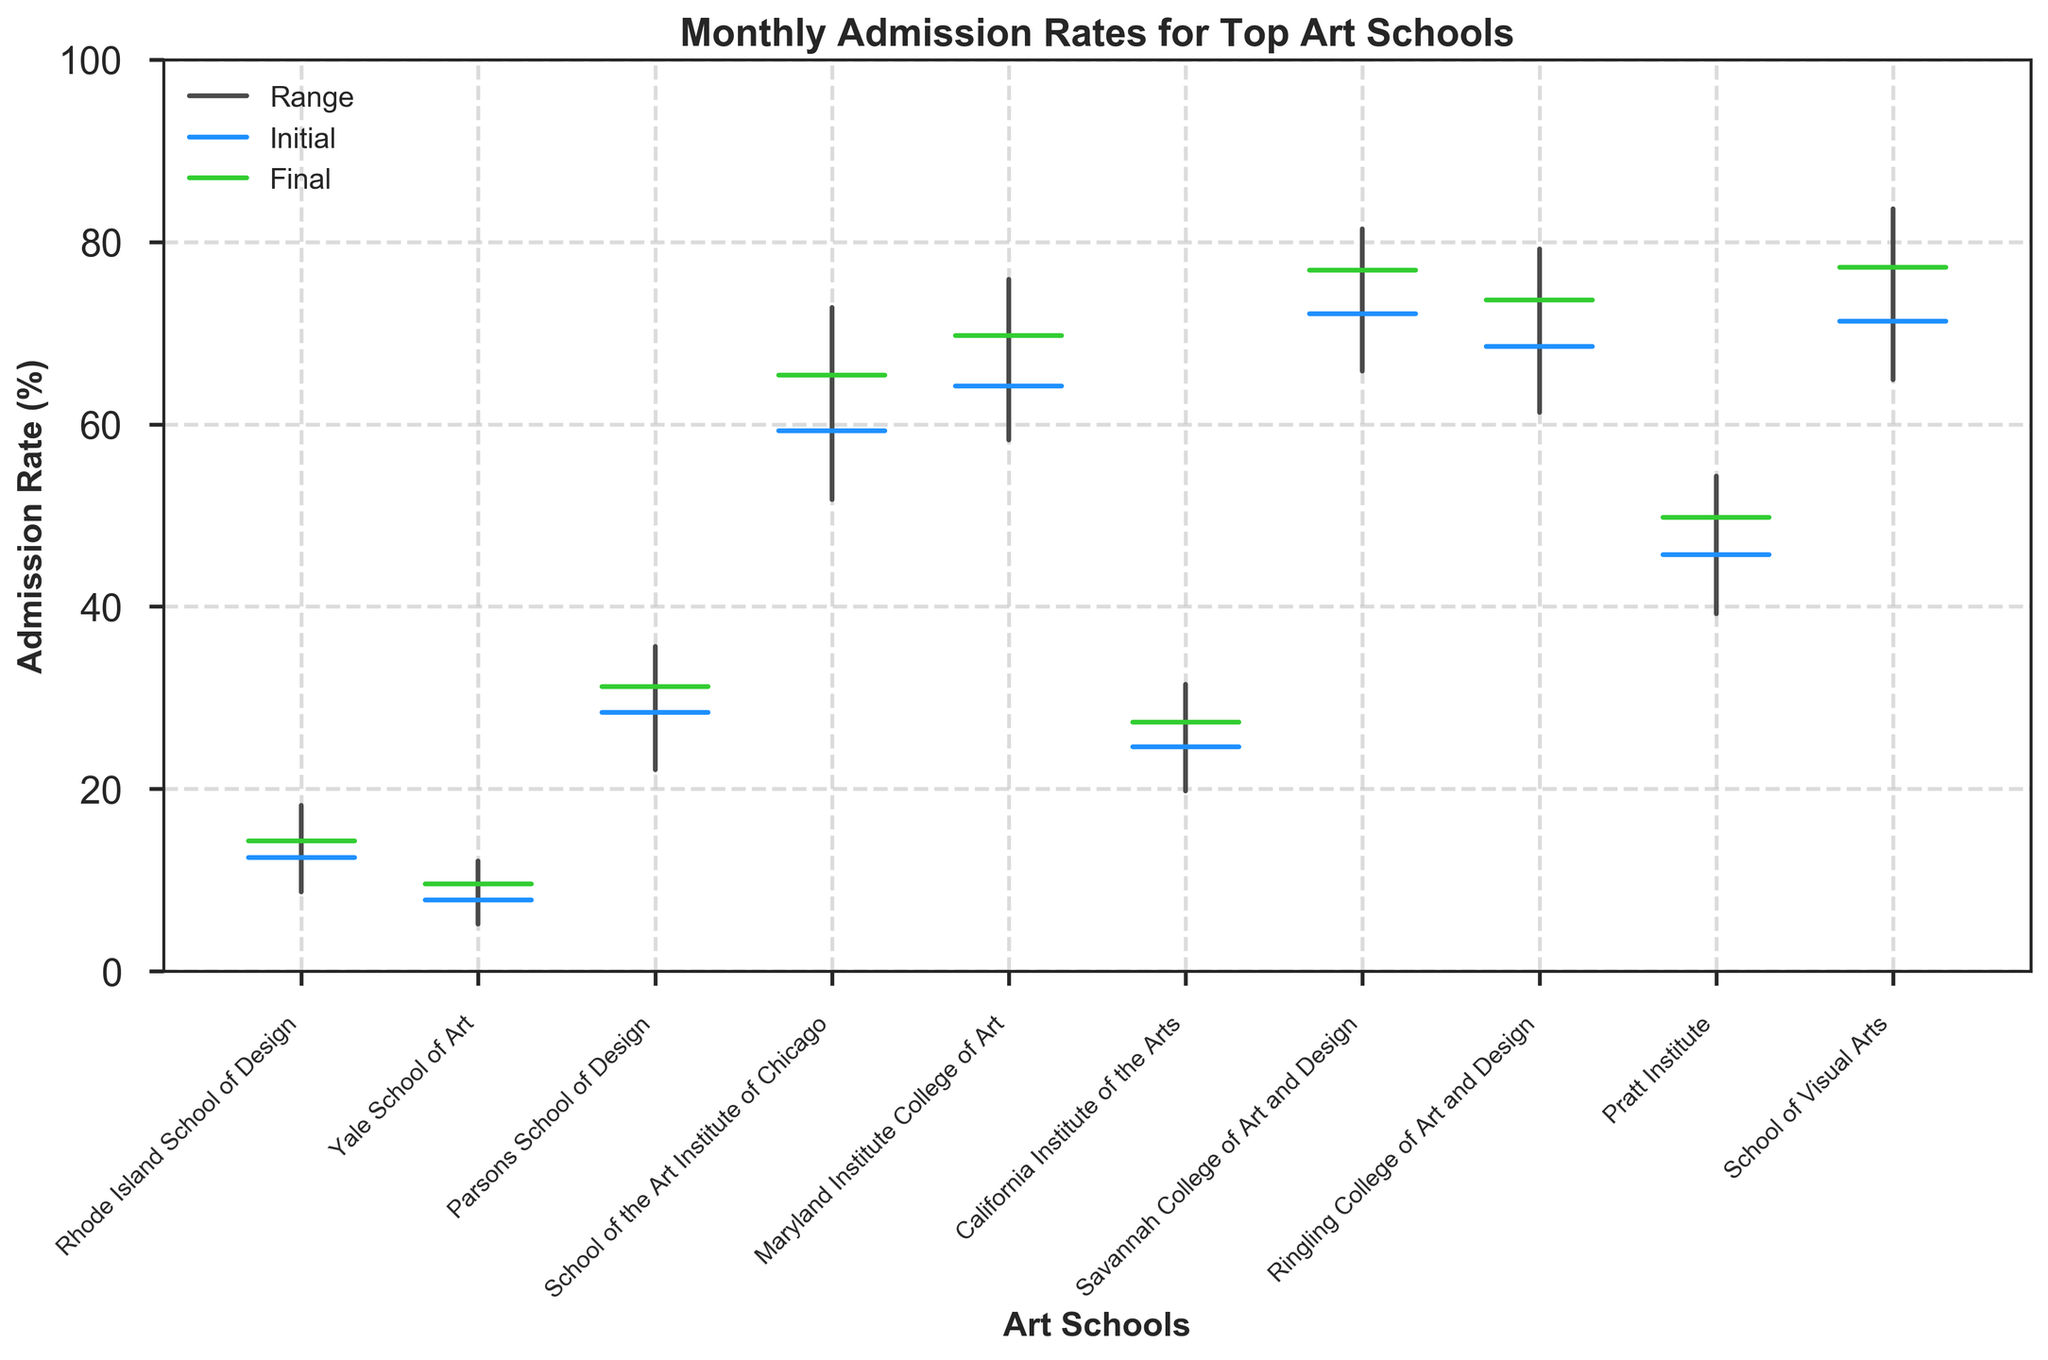What's the title of the figure? The title can be found at the top of the figure, indicating the context of the data presented. The title is "Monthly Admission Rates for Top Art Schools."
Answer: Monthly Admission Rates for Top Art Schools Which school has the highest peak admission rate? To determine this, locate the school with the highest point on the 'Peak' line in the figure. The School of Visual Arts has the highest peak rate at 83.6%.
Answer: School of Visual Arts Which school saw the greatest difference between its lowest and peak admission rates? Calculate the difference between the peak and lowest rates for each school and identify the largest gap. The School of Visual Arts has the greatest difference (83.6 - 64.9 = 18.7 percentage points).
Answer: School of Visual Arts What is the final acceptance percentage for Rhode Island School of Design? Refer to the 'Final' horizontal line for Rhode Island School of Design in the figure, which represents the percentage. The value is 14.3%.
Answer: 14.3% Which school had its final admission rate lower than its initial rate? Compare the initial and final rates for each school in the figure to find the one(s) where the final rate is lower. The Yale School of Art had its final rate (9.6%) lower than its initial rate (7.8%).
Answer: Yale School of Art What is the range of admission rates for Parsons School of Design? Find the highest (peak) and the lowest rates for Parsons School of Design and calculate the range. The peak is 35.6% and the lowest is 22.1%, hence the range is 35.6 - 22.1 = 13.5 percentage points.
Answer: 13.5 percentage points Which two schools had the highest final admission rates? Check the final rates for all schools and identify the two highest values. Savannah College of Art and Design (76.9%) and School of Visual Arts (77.2%) had the highest final rates.
Answer: Savannah College of Art and Design, School of Visual Arts Which school's admission rate showed the most stability, with the smallest difference between the initial and final rates? Subtract the final rate from the initial rate for each school and look for the smallest result. Rhode Island School of Design has the smallest difference (14.3 - 12.5 = 1.8 percentage points).
Answer: Rhode Island School of Design 